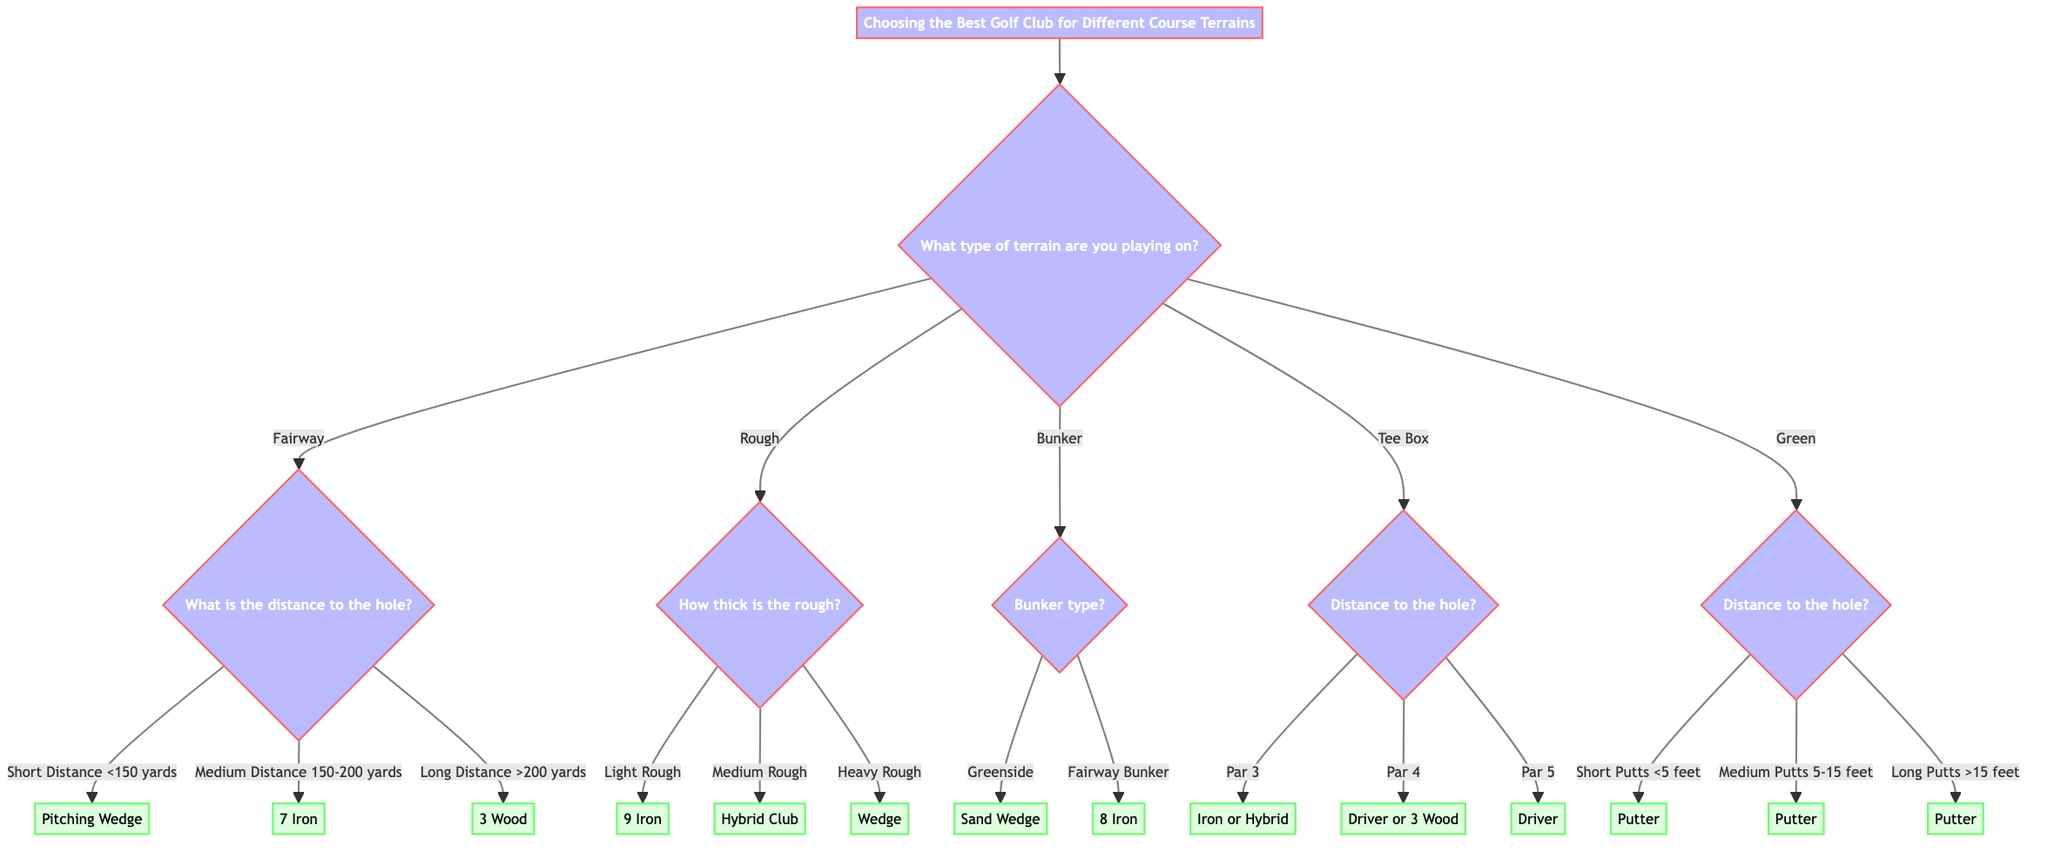What is the first question in the decision tree? The first question in the decision tree asks about the type of terrain the player is playing on, which helps to determine the appropriate branch for choosing a golf club.
Answer: What type of terrain are you playing on? How many distinct terrains does the diagram specify? The diagram specifies a total of five distinct terrains: Fairway, Rough, Bunker, Tee Box, and Green. Each terrain leads to a different set of questions concerning the selection of the golf club.
Answer: 5 What club should be used for Heavy Rough? According to the diagram, in the Heavy Rough category, the recommended club is a Wedge, which is appropriate for situations with thicker grass.
Answer: Wedge If a player is on a Fairway with a Medium Distance to the hole, which club should they select? Based on the decision tree, if the player is on the Fairway and the distance to the hole is between 150-200 yards, the selected club should be a 7 Iron.
Answer: 7 Iron What club is suggested for a Par 5 from the Tee Box? Referring to the diagram, when the player is on the Tee Box and facing a Par 5 hole, the recommendation is to use a Driver. This decision is made based on the length of the hole.
Answer: Driver If the distance for a Green putt is more than 15 feet, what club will you use? The decision tree indicates that for long putts (>15 feet) on the Green, the suggested club is a Putter, which is standard for all putting scenarios.
Answer: Putter Which club is ideal for a Greenside bunker type? According to the information provided in the diagram, when facing a Greenside bunker, the ideal club choice is a Sand Wedge, as it is specifically designed for such situations.
Answer: Sand Wedge What type of terrain leads to a question regarding bunker type? The terrain that leads to a question about bunker type is Bunker itself; this question determines the appropriate club based on the type of bunker encountered.
Answer: Bunker What option is given for Short Putts on the Green? The diagram lists the Putter for Short Putts (<5 feet) on the Green, reflecting standard practice in golf for very short distances.
Answer: Putter 